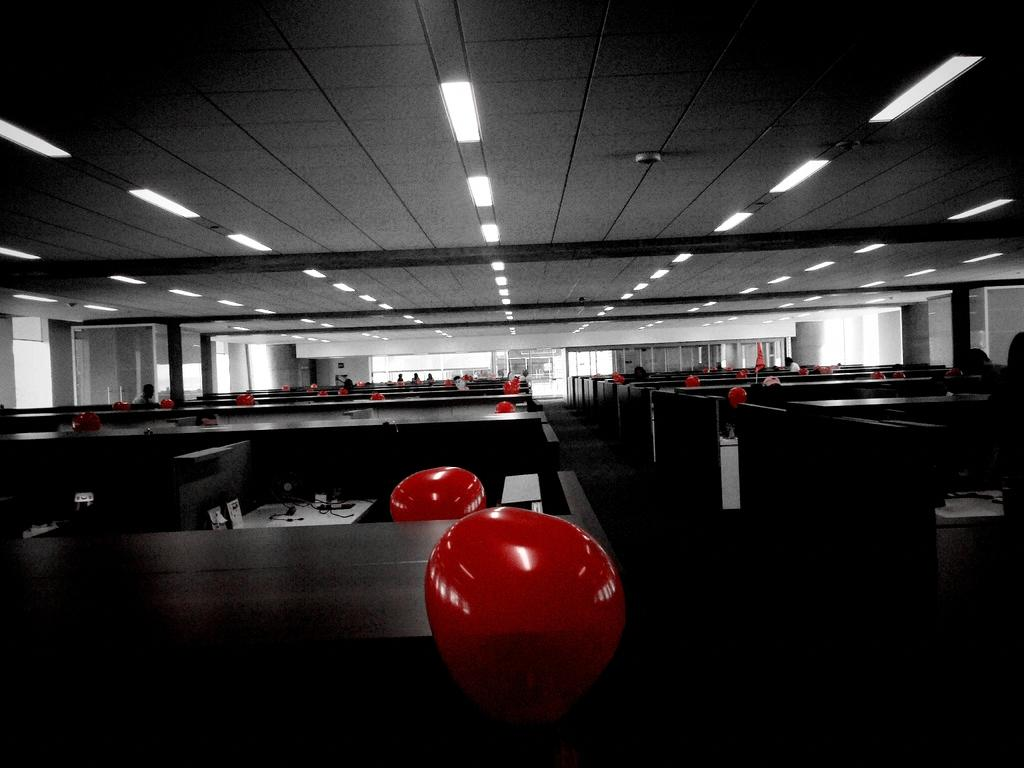What can be seen floating in the image? There are balloons in the image. What type of structures are present in the image? There are cabins in the image. What piece of furniture can be seen in the image? There is a table in the image. How many people are visible in the image? There are persons in the image. What type of illumination is present in the image? There are lights in the image. What part of the building is visible in the image? There is a ceiling in the image. What architectural feature allows for natural light and a view of the outdoors? There are windows in the image. What feature allows for entry and exit in the image? There is a door in the image. What type of range can be seen in the image? There is no range present in the image. What effect does the lighting have on the persons in the image? The provided facts do not mention any specific effect the lighting has on the persons in the image. What type of ring can be seen on the table in the image? There is no ring present on the table in the image. 